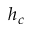<formula> <loc_0><loc_0><loc_500><loc_500>h _ { c }</formula> 